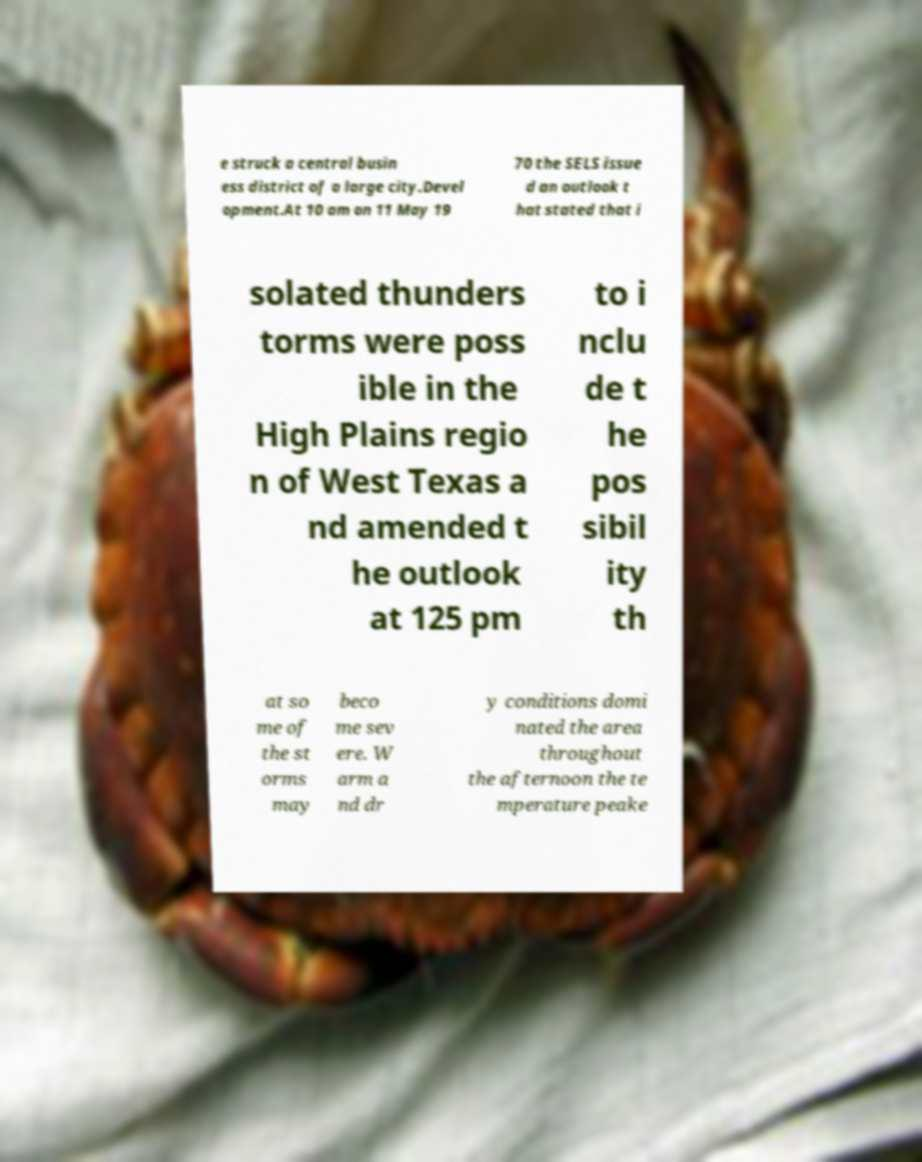I need the written content from this picture converted into text. Can you do that? e struck a central busin ess district of a large city.Devel opment.At 10 am on 11 May 19 70 the SELS issue d an outlook t hat stated that i solated thunders torms were poss ible in the High Plains regio n of West Texas a nd amended t he outlook at 125 pm to i nclu de t he pos sibil ity th at so me of the st orms may beco me sev ere. W arm a nd dr y conditions domi nated the area throughout the afternoon the te mperature peake 